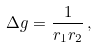Convert formula to latex. <formula><loc_0><loc_0><loc_500><loc_500>\Delta g = \frac { 1 } { r _ { 1 } r _ { 2 } } \, ,</formula> 